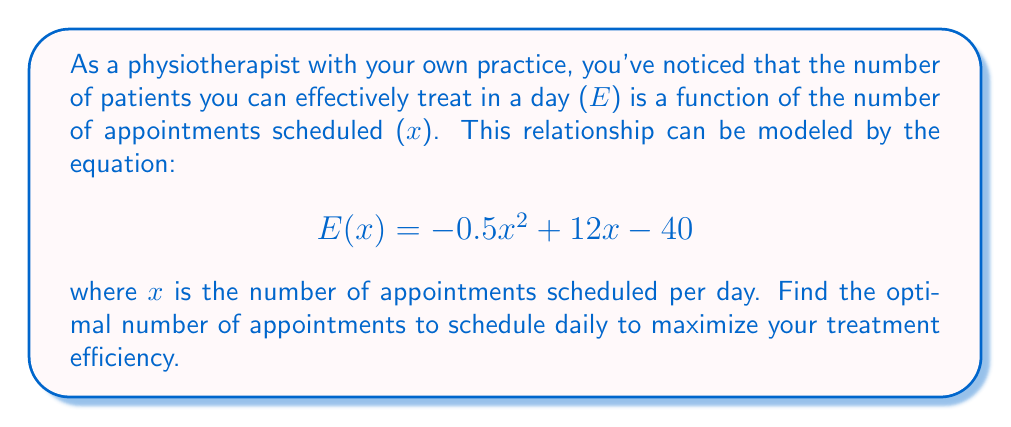What is the answer to this math problem? To find the maximum efficiency point, we need to find the value of x where the derivative of E(x) equals zero.

Step 1: Calculate the derivative of E(x)
$$E'(x) = \frac{d}{dx}(-0.5x^2 + 12x - 40)$$
$$E'(x) = -x + 12$$

Step 2: Set the derivative equal to zero and solve for x
$$E'(x) = 0$$
$$-x + 12 = 0$$
$$x = 12$$

Step 3: Verify that this is a maximum point
To confirm this is a maximum, we can check the second derivative:
$$E''(x) = \frac{d}{dx}(-x + 12) = -1$$
Since $E''(x)$ is negative, we confirm that x = 12 is indeed a maximum point.

Step 4: Interpret the result
The optimal number of appointments to schedule daily is 12. This will maximize your treatment efficiency.
Answer: 12 appointments per day 